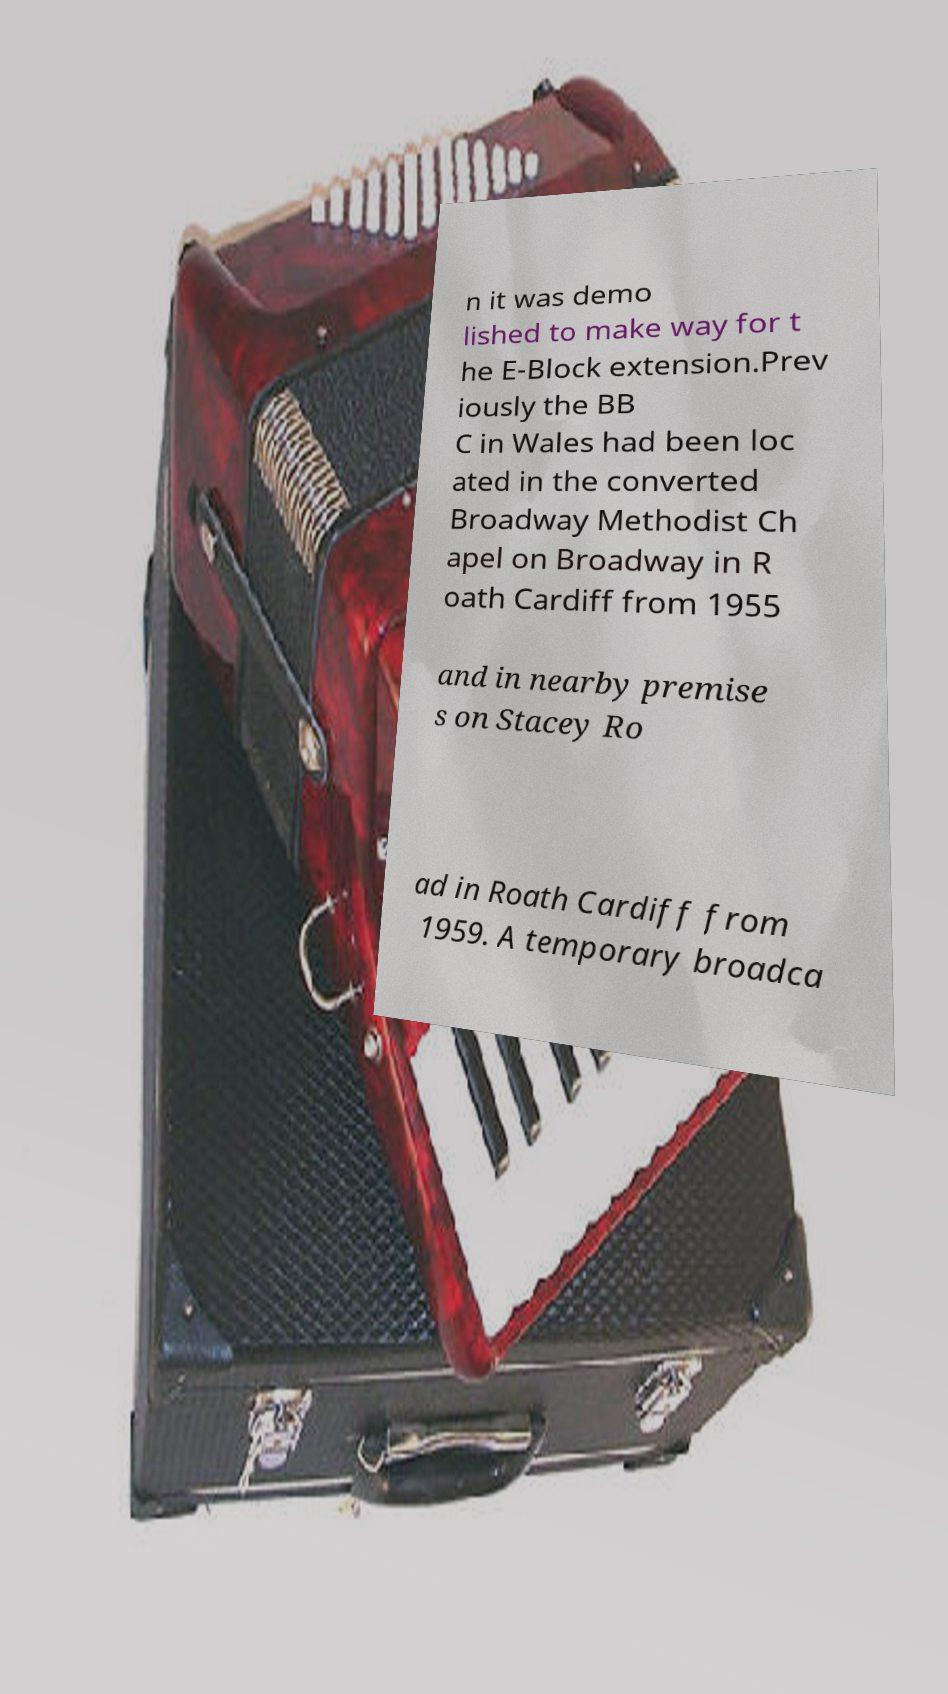Could you assist in decoding the text presented in this image and type it out clearly? n it was demo lished to make way for t he E-Block extension.Prev iously the BB C in Wales had been loc ated in the converted Broadway Methodist Ch apel on Broadway in R oath Cardiff from 1955 and in nearby premise s on Stacey Ro ad in Roath Cardiff from 1959. A temporary broadca 